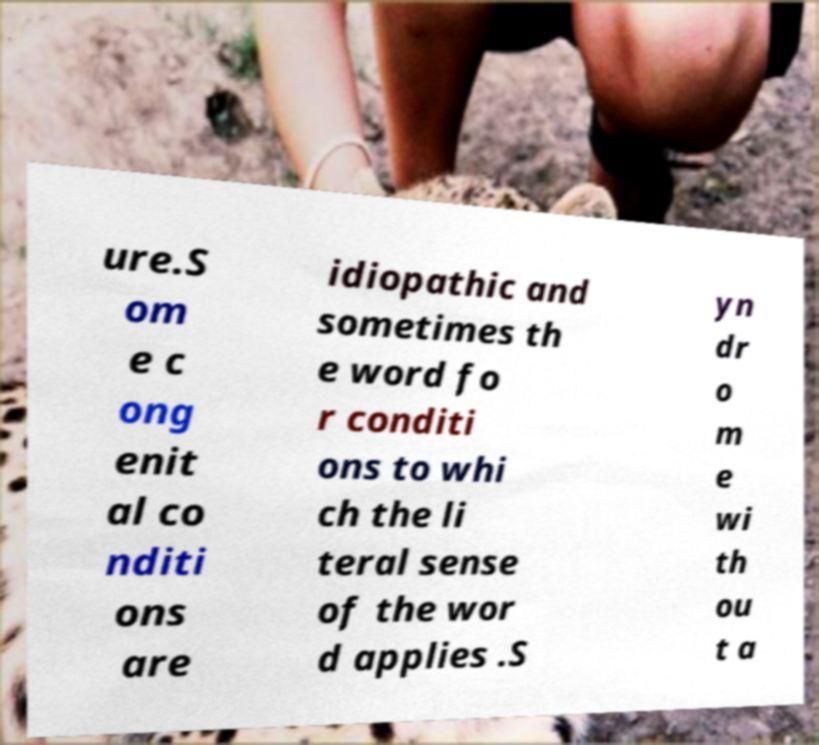Please read and relay the text visible in this image. What does it say? ure.S om e c ong enit al co nditi ons are idiopathic and sometimes th e word fo r conditi ons to whi ch the li teral sense of the wor d applies .S yn dr o m e wi th ou t a 